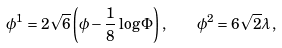<formula> <loc_0><loc_0><loc_500><loc_500>\phi ^ { 1 } = 2 \sqrt { 6 } \left ( { \phi } - \frac { 1 } { 8 } \log \Phi \right ) , \quad \phi ^ { 2 } = 6 \sqrt { 2 } { \lambda } \, ,</formula> 